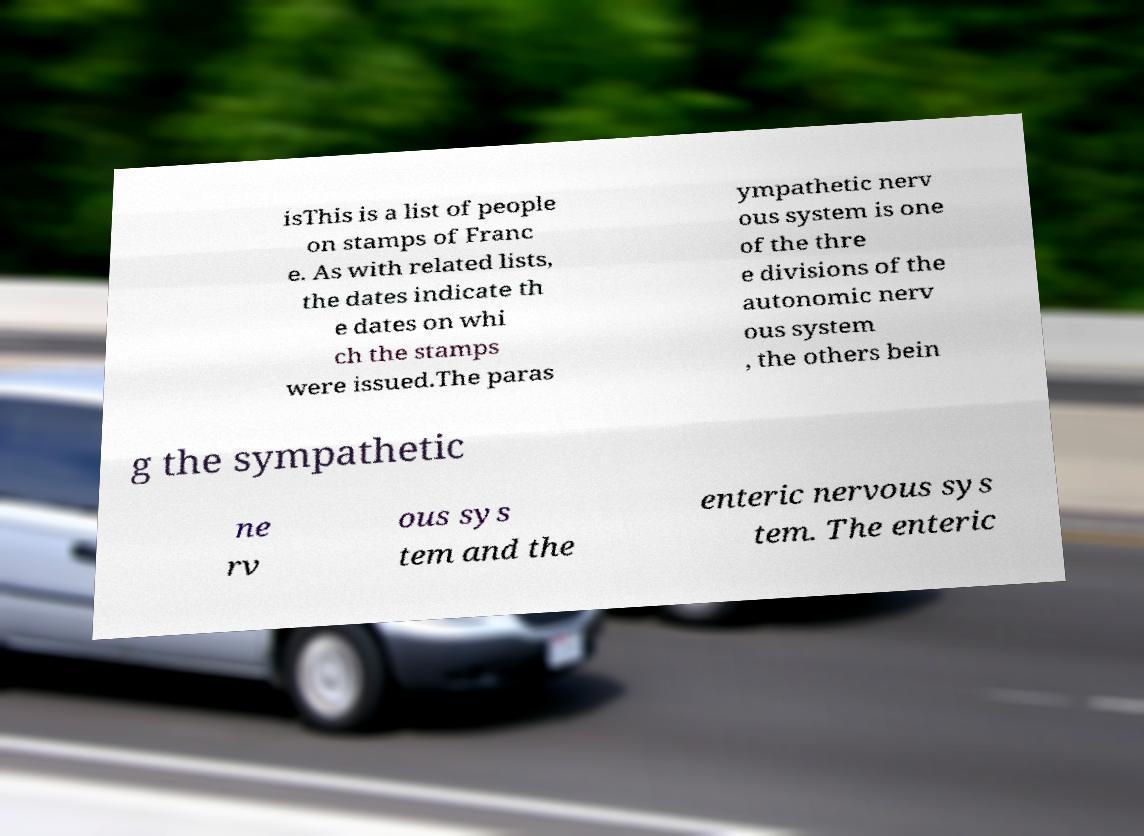Please read and relay the text visible in this image. What does it say? isThis is a list of people on stamps of Franc e. As with related lists, the dates indicate th e dates on whi ch the stamps were issued.The paras ympathetic nerv ous system is one of the thre e divisions of the autonomic nerv ous system , the others bein g the sympathetic ne rv ous sys tem and the enteric nervous sys tem. The enteric 